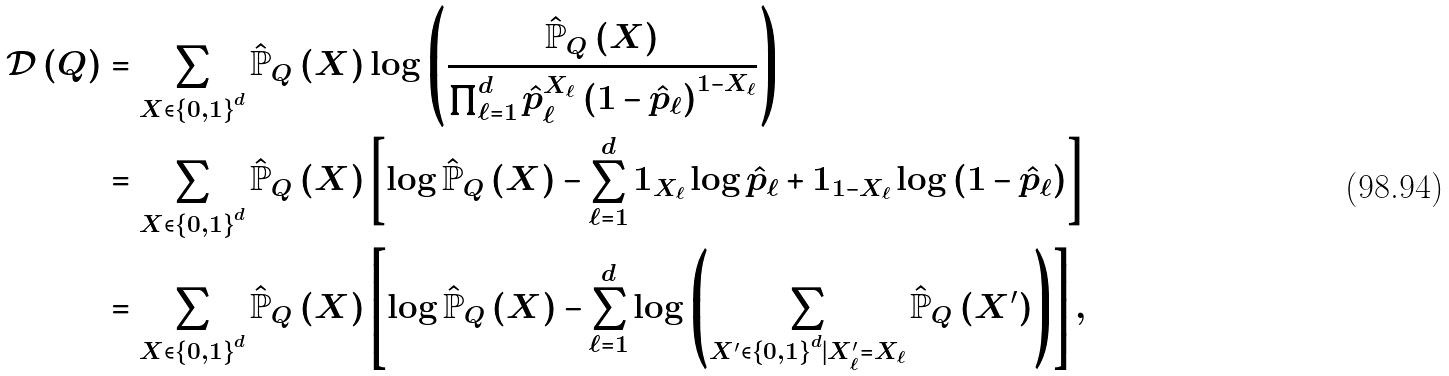Convert formula to latex. <formula><loc_0><loc_0><loc_500><loc_500>\mathcal { D } \left ( Q \right ) & = \sum _ { X \in \left \{ 0 , 1 \right \} ^ { d } } \hat { \mathbb { P } } _ { Q } \left ( X \right ) \log \left ( \frac { \hat { \mathbb { P } } _ { Q } \left ( X \right ) } { \prod _ { \ell = 1 } ^ { d } \hat { p } _ { \ell } ^ { X _ { \ell } } \left ( 1 - \hat { p } _ { \ell } \right ) ^ { 1 - X _ { \ell } } } \right ) \\ & = \sum _ { X \in \left \{ 0 , 1 \right \} ^ { d } } \hat { \mathbb { P } } _ { Q } \left ( X \right ) \left [ \log \hat { \mathbb { P } } _ { Q } \left ( X \right ) - \sum _ { \ell = 1 } ^ { d } 1 _ { X _ { \ell } } \log \hat { p } _ { \ell } + 1 _ { 1 - X _ { \ell } } \log \left ( 1 - \hat { p } _ { \ell } \right ) \right ] \\ & = \sum _ { X \in \left \{ 0 , 1 \right \} ^ { d } } \hat { \mathbb { P } } _ { Q } \left ( X \right ) \left [ \log \hat { \mathbb { P } } _ { Q } \left ( X \right ) - \sum _ { \ell = 1 } ^ { d } \log \left ( \sum _ { X ^ { \prime } \in \left \{ 0 , 1 \right \} ^ { d } | X ^ { \prime } _ { \ell } = X _ { \ell } } \hat { \mathbb { P } } _ { Q } \left ( X ^ { \prime } \right ) \right ) \right ] ,</formula> 